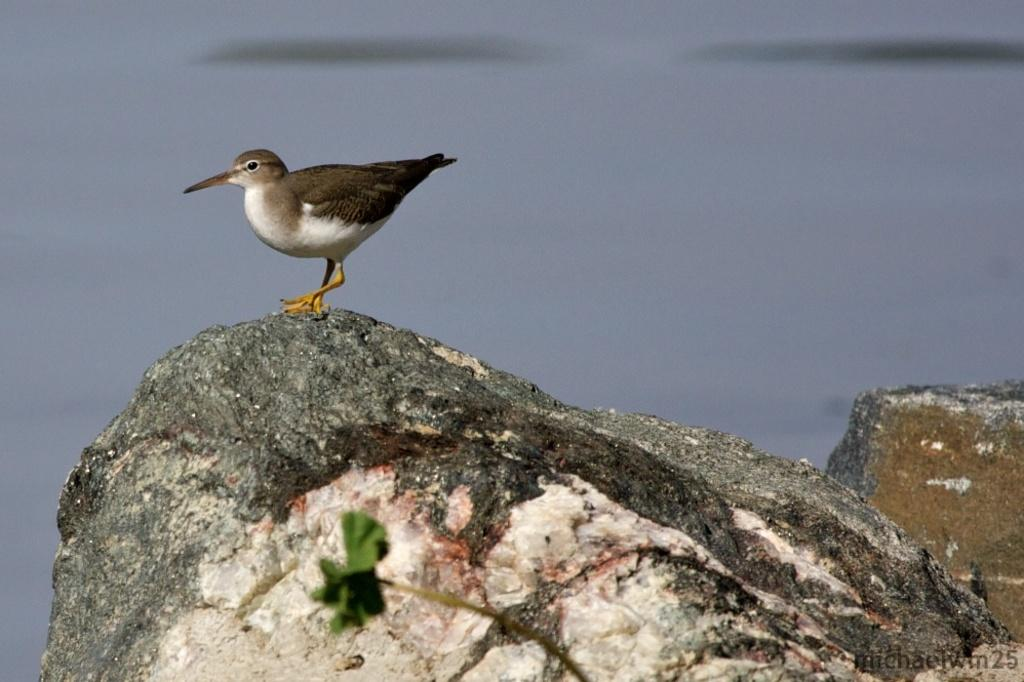What animal is present in the image? There is a bird on a stone in the image. What other living organism can be seen in the image? There is a plant in the image. Can you describe the background of the image? The background of the image is not clear. What type of pet is visible in the image? There is no pet present in the image; it features a bird on a stone and a plant. What kind of shock can be seen in the image? There is no shock present in the image. 